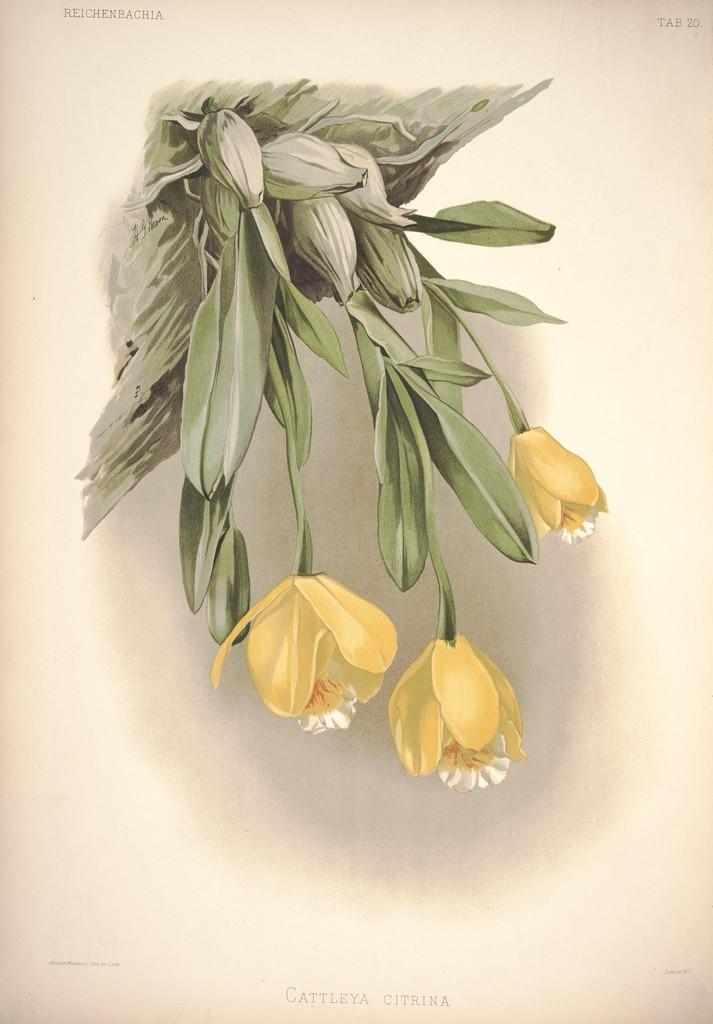Can you describe this image briefly? In this image, we can see a plant contains flowers and buds. 